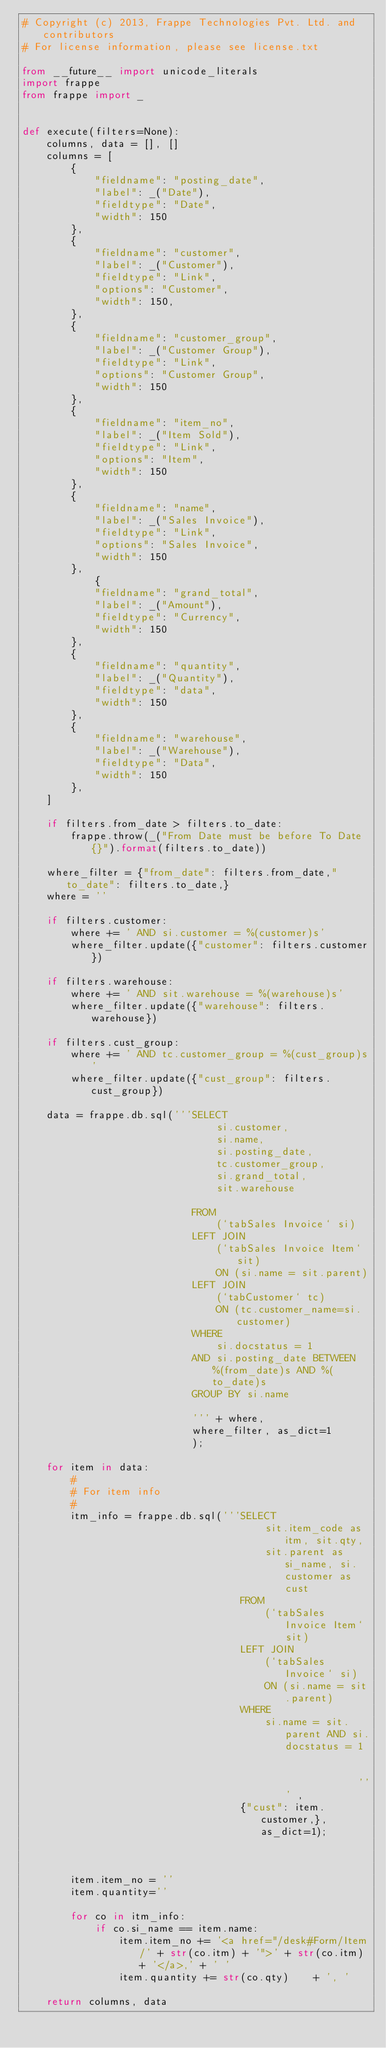Convert code to text. <code><loc_0><loc_0><loc_500><loc_500><_Python_># Copyright (c) 2013, Frappe Technologies Pvt. Ltd. and contributors
# For license information, please see license.txt

from __future__ import unicode_literals
import frappe
from frappe import _


def execute(filters=None):
	columns, data = [], []
	columns = [
		{
			"fieldname": "posting_date",
			"label": _("Date"),
			"fieldtype": "Date",
			"width": 150
		},
		{
			"fieldname": "customer",
			"label": _("Customer"),
			"fieldtype": "Link",
			"options": "Customer",
			"width": 150,
		},
		{
			"fieldname": "customer_group",
			"label": _("Customer Group"),
			"fieldtype": "Link",
			"options": "Customer Group",
			"width": 150
		},
		{
			"fieldname": "item_no",
			"label": _("Item Sold"),
			"fieldtype": "Link",
			"options": "Item",
			"width": 150
		},
		{
			"fieldname": "name",
			"label": _("Sales Invoice"),
			"fieldtype": "Link",
			"options": "Sales Invoice",
			"width": 150		
		},
			{
			"fieldname": "grand_total",
			"label": _("Amount"),
			"fieldtype": "Currency",
			"width": 150
		},
		{
			"fieldname": "quantity",
			"label": _("Quantity"),
			"fieldtype": "data",
			"width": 150
		},
		{
			"fieldname": "warehouse",
			"label": _("Warehouse"),
			"fieldtype": "Data",
			"width": 150
		},
	]

	if filters.from_date > filters.to_date:
		frappe.throw(_("From Date must be before To Date {}").format(filters.to_date))

	where_filter = {"from_date": filters.from_date,"to_date": filters.to_date,}
	where = ''

	if filters.customer:
		where += ' AND si.customer = %(customer)s'
		where_filter.update({"customer": filters.customer})
	
	if filters.warehouse:
		where += ' AND sit.warehouse = %(warehouse)s'
		where_filter.update({"warehouse": filters.warehouse})

	if filters.cust_group:
		where += ' AND tc.customer_group = %(cust_group)s'
		where_filter.update({"cust_group": filters.cust_group})
	
	data = frappe.db.sql('''SELECT 
								si.customer,
								si.name,
								si.posting_date,
								tc.customer_group,
								si.grand_total,
								sit.warehouse

							FROM
								(`tabSales Invoice` si)
							LEFT JOIN
								(`tabSales Invoice Item` sit)
								ON (si.name = sit.parent)
							LEFT JOIN
								(`tabCustomer` tc)
								ON (tc.customer_name=si.customer)
							WHERE
							 	si.docstatus = 1
							AND si.posting_date BETWEEN %(from_date)s AND %(to_date)s
							GROUP BY si.name						
							''' + where,
							where_filter, as_dict=1
							);

	for item in data:
		#
		# For item info
		#
		itm_info = frappe.db.sql('''SELECT 
										sit.item_code as itm, sit.qty,
										sit.parent as si_name, si.customer as cust
									FROM 
										(`tabSales Invoice Item` sit) 
									LEFT JOIN
										(`tabSales Invoice` si)
										ON (si.name = sit.parent)
									WHERE 
										si.name = sit.parent AND si.docstatus = 1									''' , 
									{"cust": item.customer,}, as_dict=1);								
									
		item.item_no = ''
		item.quantity=''

		for co in itm_info:
			if co.si_name == item.name:
				item.item_no += '<a href="/desk#Form/Item/' + str(co.itm) + '">' + str(co.itm) + '</a>,' + ' '
				item.quantity += str(co.qty)	+ ', '

	return columns, data
</code> 